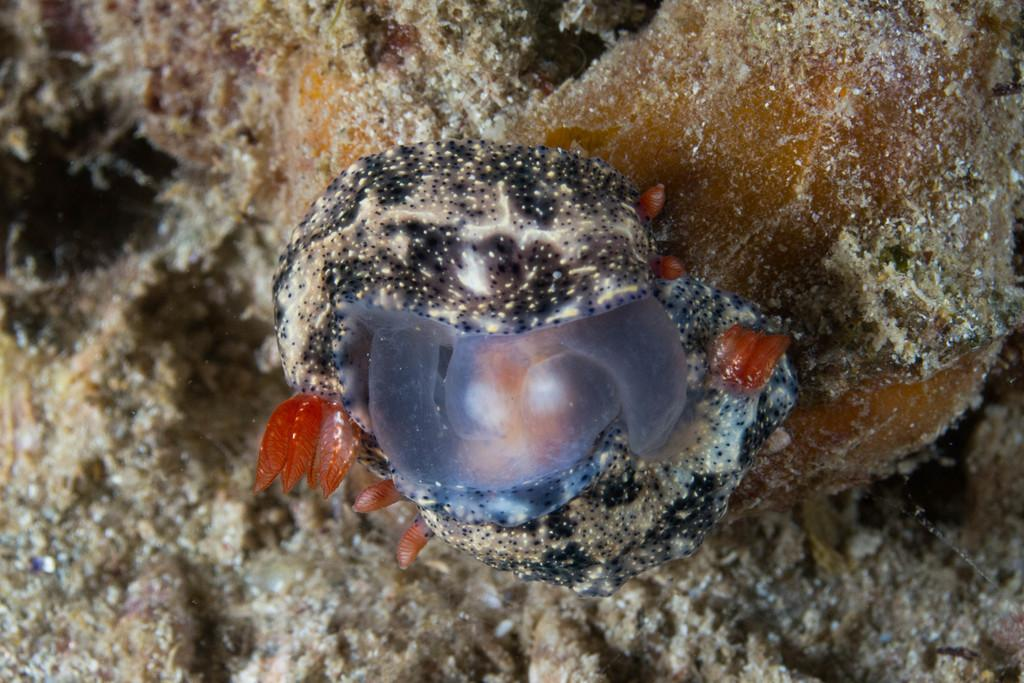What is the main subject of the image? There is an animal in the water in the image. Can you describe the animal's location in the image? The animal is in the water. What type of environment is depicted in the image? The image shows a water environment. What type of tree can be seen sparking in the image? There is no tree or spark present in the image; it only features an animal in the water. 